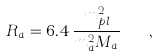Convert formula to latex. <formula><loc_0><loc_0><loc_500><loc_500>R _ { a } = 6 . 4 \, \frac { m _ { p l } ^ { 2 } } { m _ { a } ^ { 2 } M _ { a } } \quad ,</formula> 